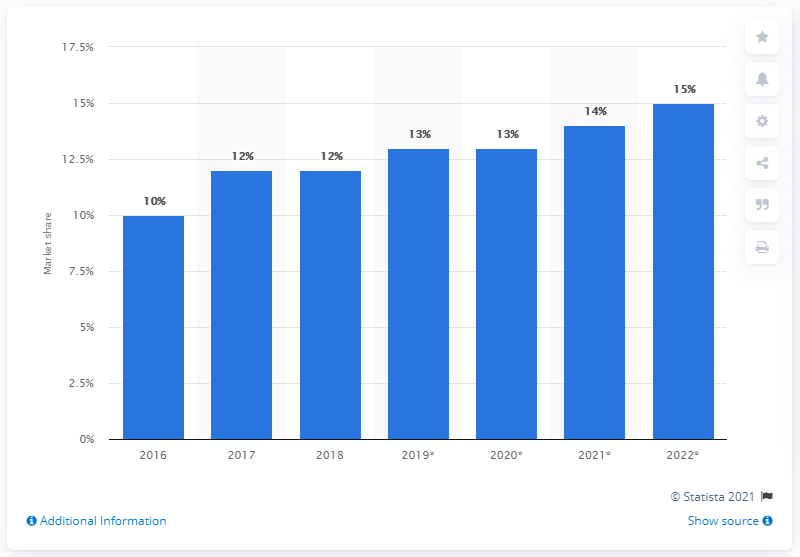Draw attention to some important aspects in this diagram. According to predictions, by 2022, DoorDash's share of the food delivery market is expected to increase to 15%. 